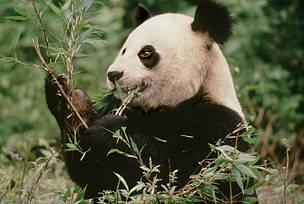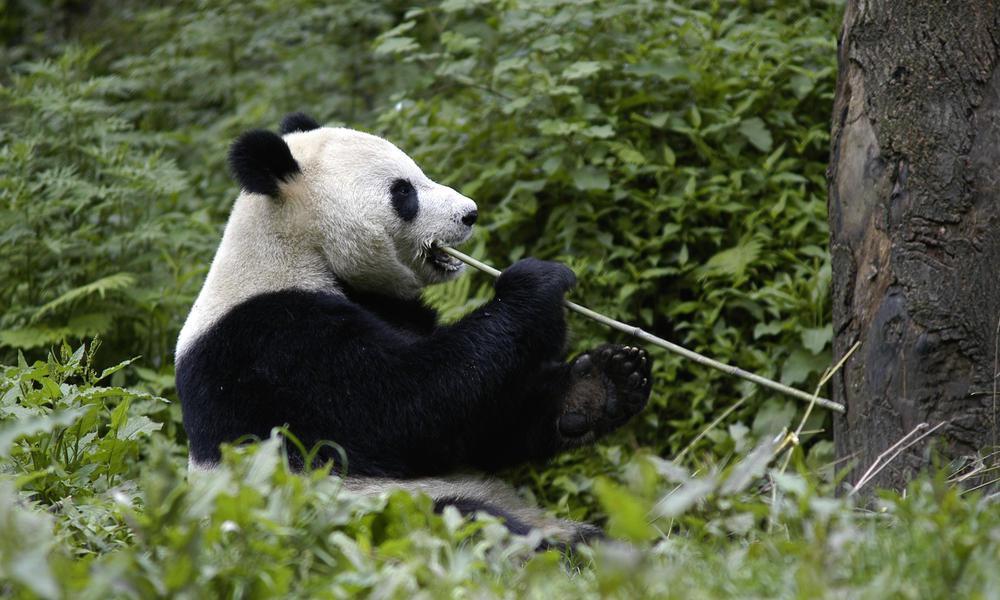The first image is the image on the left, the second image is the image on the right. Given the left and right images, does the statement "There is a lone panda bear sitting down while eating some bamboo." hold true? Answer yes or no. Yes. 